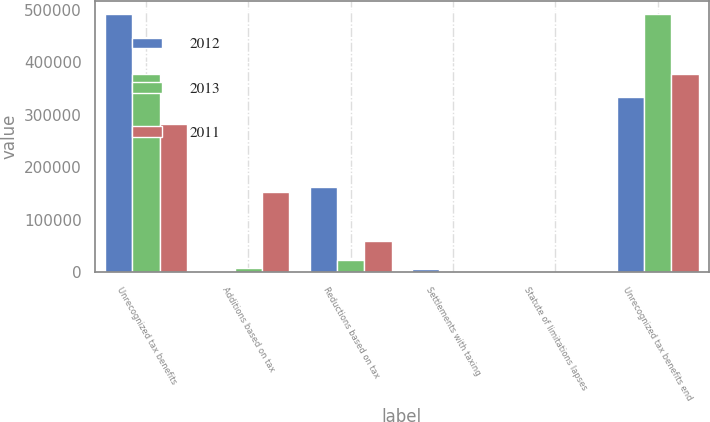Convert chart. <chart><loc_0><loc_0><loc_500><loc_500><stacked_bar_chart><ecel><fcel>Unrecognized tax benefits<fcel>Additions based on tax<fcel>Reductions based on tax<fcel>Settlements with taxing<fcel>Statute of limitations lapses<fcel>Unrecognized tax benefits end<nl><fcel>2012<fcel>491973<fcel>117<fcel>162942<fcel>5225<fcel>1342<fcel>332933<nl><fcel>2013<fcel>377405<fcel>8425<fcel>23167<fcel>99<fcel>1034<fcel>491973<nl><fcel>2011<fcel>281666<fcel>152497<fcel>59315<fcel>422<fcel>1195<fcel>377405<nl></chart> 